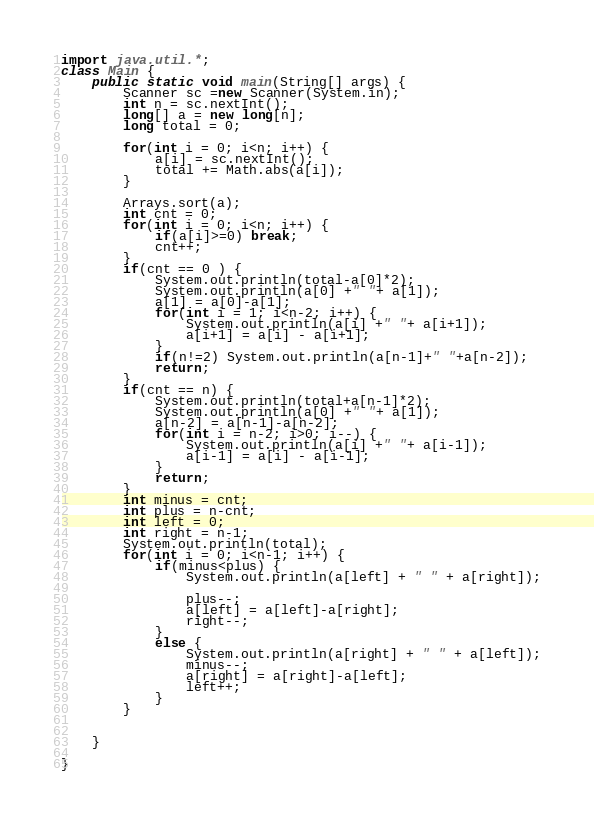<code> <loc_0><loc_0><loc_500><loc_500><_Java_>import java.util.*;
class Main {
    public static void main(String[] args) {
        Scanner sc =new Scanner(System.in);
        int n = sc.nextInt();
        long[] a = new long[n];
        long total = 0;

        for(int i = 0; i<n; i++) {
            a[i] = sc.nextInt();
            total += Math.abs(a[i]);
        }

        Arrays.sort(a);
        int cnt = 0;
        for(int i = 0; i<n; i++) {
            if(a[i]>=0) break;
            cnt++;
        }
        if(cnt == 0 ) {
            System.out.println(total-a[0]*2);
            System.out.println(a[0] +" "+ a[1]);
            a[1] = a[0]-a[1];
            for(int i = 1; i<n-2; i++) {
                System.out.println(a[i] +" "+ a[i+1]);
                a[i+1] = a[i] - a[i+1];
            }
            if(n!=2) System.out.println(a[n-1]+" "+a[n-2]);
            return;
        }
        if(cnt == n) {
            System.out.println(total+a[n-1]*2);
            System.out.println(a[0] +" "+ a[1]);
            a[n-2] = a[n-1]-a[n-2];
            for(int i = n-2; i>0; i--) {
                System.out.println(a[i] +" "+ a[i-1]);
                a[i-1] = a[i] - a[i-1];
            }
            return;
        }
        int minus = cnt;
        int plus = n-cnt;
        int left = 0;
        int right = n-1;
        System.out.println(total);
        for(int i = 0; i<n-1; i++) {
            if(minus<plus) {
                System.out.println(a[left] + " " + a[right]);

                plus--;
                a[left] = a[left]-a[right];
                right--;
            }
            else {
                System.out.println(a[right] + " " + a[left]);
                minus--;
                a[right] = a[right]-a[left];
                left++;
            }
        }


    }

}</code> 